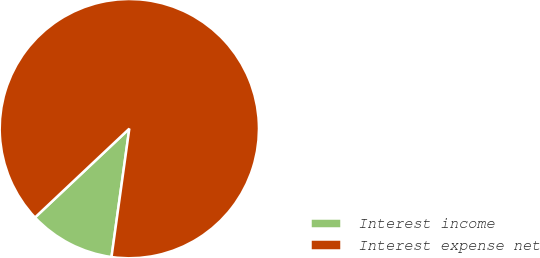Convert chart to OTSL. <chart><loc_0><loc_0><loc_500><loc_500><pie_chart><fcel>Interest income<fcel>Interest expense net<nl><fcel>10.78%<fcel>89.22%<nl></chart> 